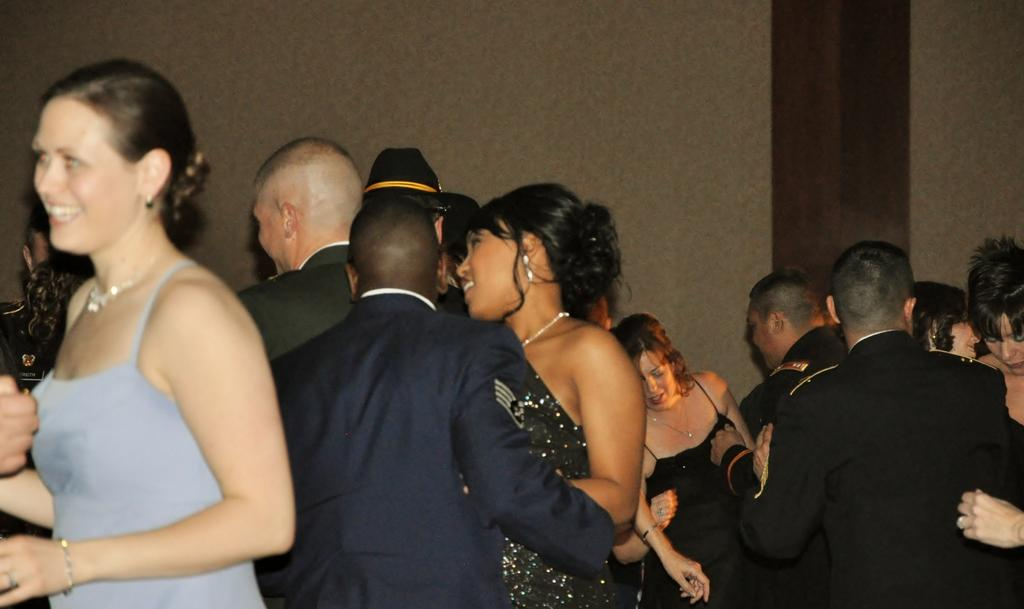How many people are in the image? There is a group of people in the image. What are some of the people doing in the image? Some of the people are smiling. What can be seen in the background of the image? There is a wall in the background of the image. What type of parent is depicted on the page in the image? There is no page or parent present in the image; it features a group of people and a wall in the background. 